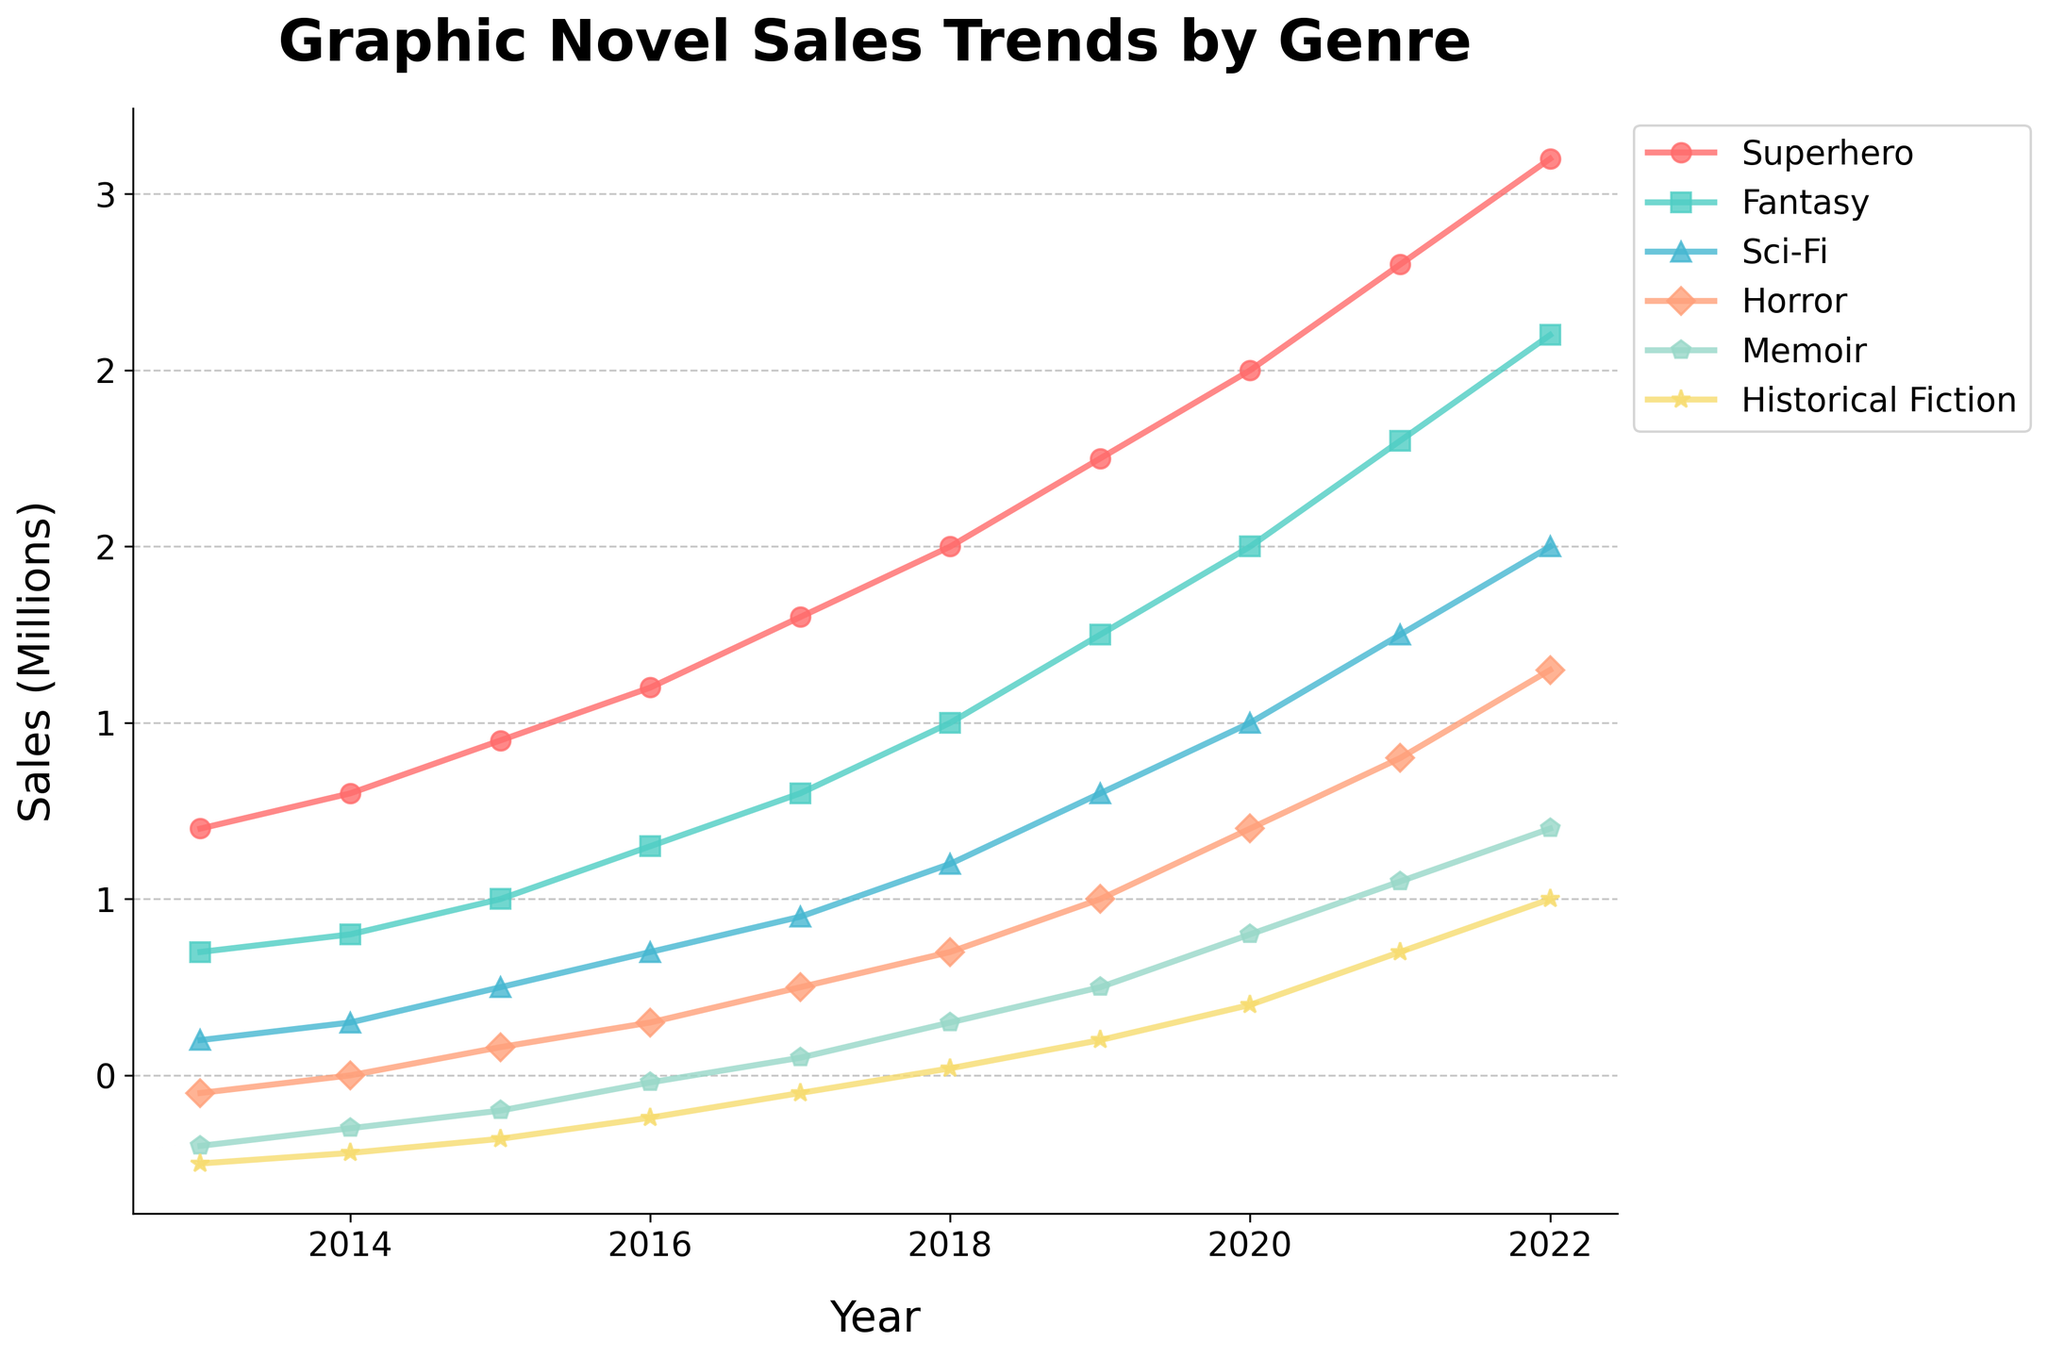What genre had the highest sales in 2013? Looking at the figure, we can identify which genre starts with the highest value on the y-axis for the year 2013.
Answer: Superhero By how much did the sales of Fantasy graphic novels increase from 2013 to 2022? Compare the Fantasy sales figures for 2013 and 2022. The difference can be calculated as Sales in 2022 minus Sales in 2013. \(2600000 - 850000 = 1750000 \).
Answer: 1,750,000 Which genre showed the most consistent year-over-year increase in sales? We observe the trend lines of each genre and see which one consistently rises without significant dips across all years. The Superhero genre shows a steady upward trend each year.
Answer: Superhero In 2020, which genre had the closest sales figures to Horror graphic novels? Check the sales figures for all genres in 2020 and compare them to the Horror genre to find the closest value. Sci-Fi at 1,500,000 is the closest to Horror's 1,200,000.
Answer: Sci-Fi What is the average sales figure for Memoir graphic novels from 2018 to 2022? Sum up the Memoir sales figures from 2018 to 2022 and then divide by the number of years. \((650000 + 750000 + 900000 + 1050000 + 1200000) / 5 = 910000\).
Answer: 910,000 Between which two consecutive years did Superhero graphic novels see the largest increase in sales? Compare the year-over-year increase in sales for the Superhero genre and identify the maximum difference. The largest increase is between 2021 and 2022, \(3100000 - 2800000 = 300000 \).
Answer: 2021 and 2022 What was the total sales of Sci-Fi graphic novels from 2013 to 2016? Sum up the Sci-Fi sales figures for each year from 2013 to 2016. \(600000 + 650000 + 750000 + 850000 = 2850000\).
Answer: 2,850,000 Which genre had a sales figure closest to 1 million in 2016? Check the sales figures for each genre in 2016 and find the one closest to 1 million. Sci-Fi at 850,000 is closest.
Answer: Sci-Fi How did the sales of Historical Fiction graphic novels in 2018 compare to those in 2020? Compare the Historical Fiction sales figures in 2018 and 2020. \(700000 - 520000 = 180000 \). So, Historical Fiction sales in 2020 were 180,000 higher than in 2018.
Answer: Higher by 180,000 In what year did Horror graphic novels surpass the sales figure of 1 million? Refer to the trend line for Horror graphic novels to identify the first year when the sales figure exceeds 1 million. In 2020, the sales are 1,200,000, surpassing 1 million.
Answer: 2020 